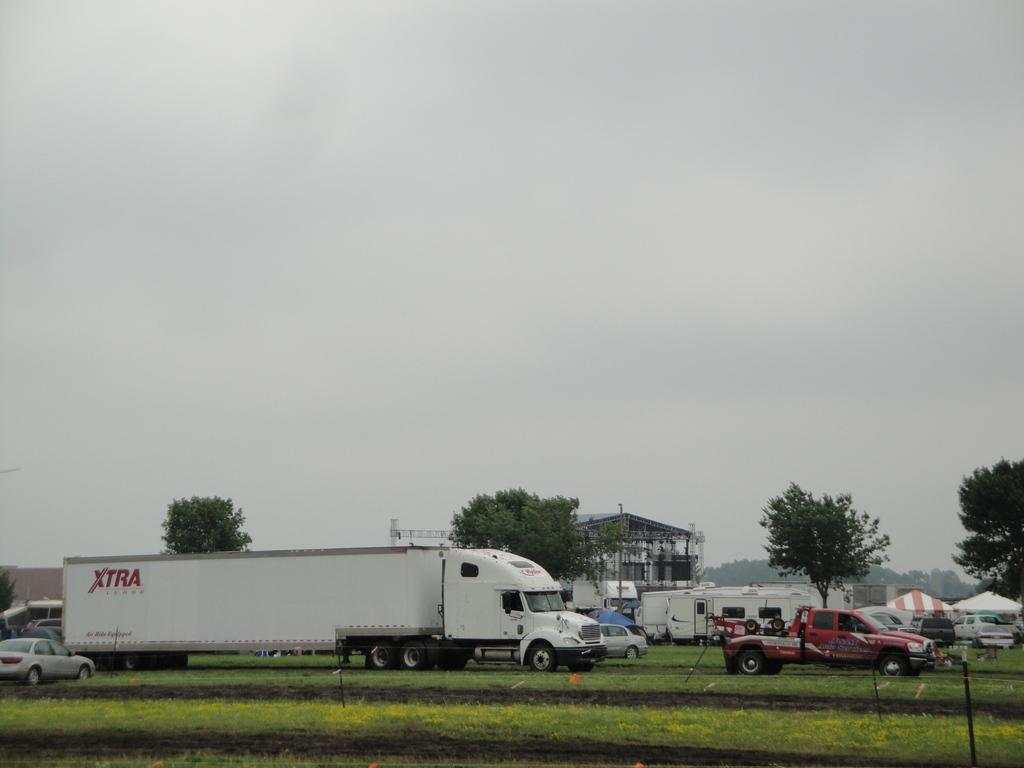What type of terrain is visible in the image? There is a land visible in the image. What can be seen on the land in the image? There are vehicles on the land in the image. What can be seen in the background of the image? There are trees and a shed in the background of the image. What is visible above the land and structures in the image? The sky is visible in the background of the image. What type of fruit is hanging from the trees in the image? There is no fruit visible in the image; only trees and a shed are present in the background. 